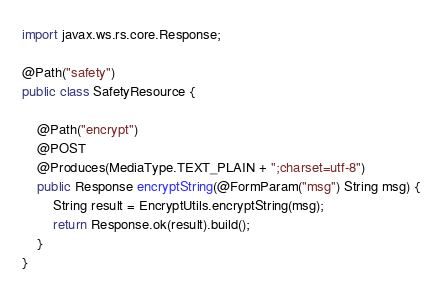<code> <loc_0><loc_0><loc_500><loc_500><_Java_>import javax.ws.rs.core.Response;

@Path("safety")
public class SafetyResource {

    @Path("encrypt")
    @POST
    @Produces(MediaType.TEXT_PLAIN + ";charset=utf-8")
    public Response encryptString(@FormParam("msg") String msg) {
        String result = EncryptUtils.encryptString(msg);
        return Response.ok(result).build();
    }
}
</code> 